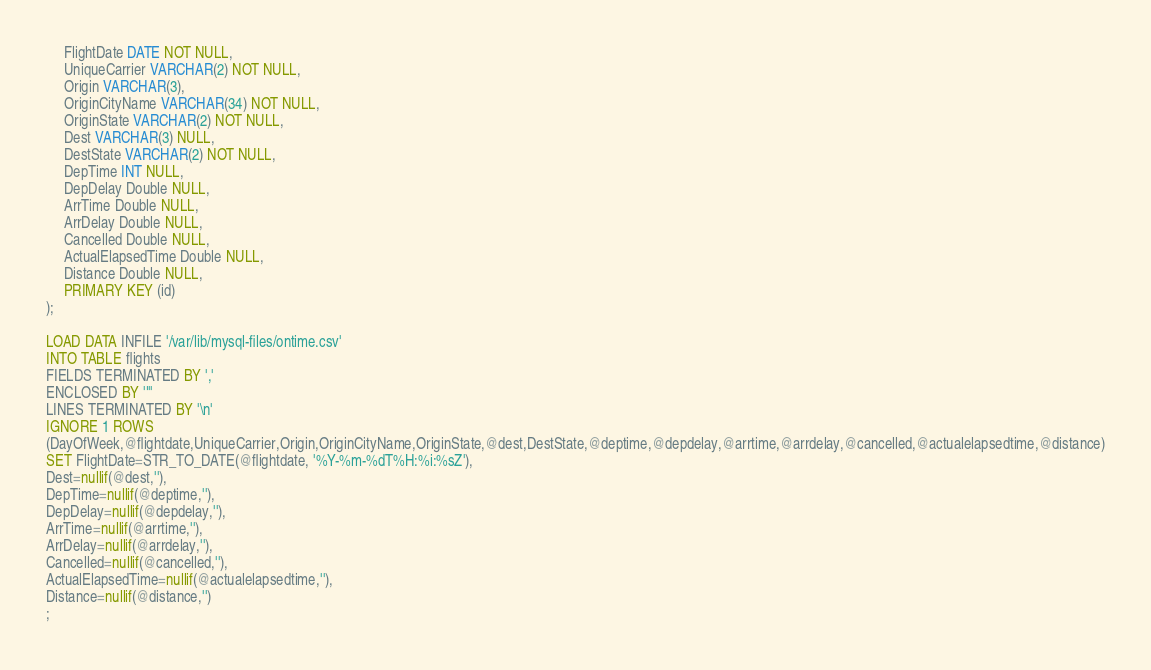Convert code to text. <code><loc_0><loc_0><loc_500><loc_500><_SQL_>     FlightDate DATE NOT NULL,
     UniqueCarrier VARCHAR(2) NOT NULL,
     Origin VARCHAR(3),
     OriginCityName VARCHAR(34) NOT NULL,
     OriginState VARCHAR(2) NOT NULL,
     Dest VARCHAR(3) NULL,
     DestState VARCHAR(2) NOT NULL,
     DepTime INT NULL,
     DepDelay Double NULL,
     ArrTime Double NULL,
     ArrDelay Double NULL,
     Cancelled Double NULL,
     ActualElapsedTime Double NULL,
     Distance Double NULL,
     PRIMARY KEY (id)
);

LOAD DATA INFILE '/var/lib/mysql-files/ontime.csv'
INTO TABLE flights
FIELDS TERMINATED BY ','
ENCLOSED BY '"'
LINES TERMINATED BY '\n'
IGNORE 1 ROWS
(DayOfWeek,@flightdate,UniqueCarrier,Origin,OriginCityName,OriginState,@dest,DestState,@deptime,@depdelay,@arrtime,@arrdelay,@cancelled,@actualelapsedtime,@distance)
SET FlightDate=STR_TO_DATE(@flightdate, '%Y-%m-%dT%H:%i:%sZ'),
Dest=nullif(@dest,''),
DepTime=nullif(@deptime,''),
DepDelay=nullif(@depdelay,''),
ArrTime=nullif(@arrtime,''),
ArrDelay=nullif(@arrdelay,''),
Cancelled=nullif(@cancelled,''),
ActualElapsedTime=nullif(@actualelapsedtime,''),
Distance=nullif(@distance,'')
;
</code> 